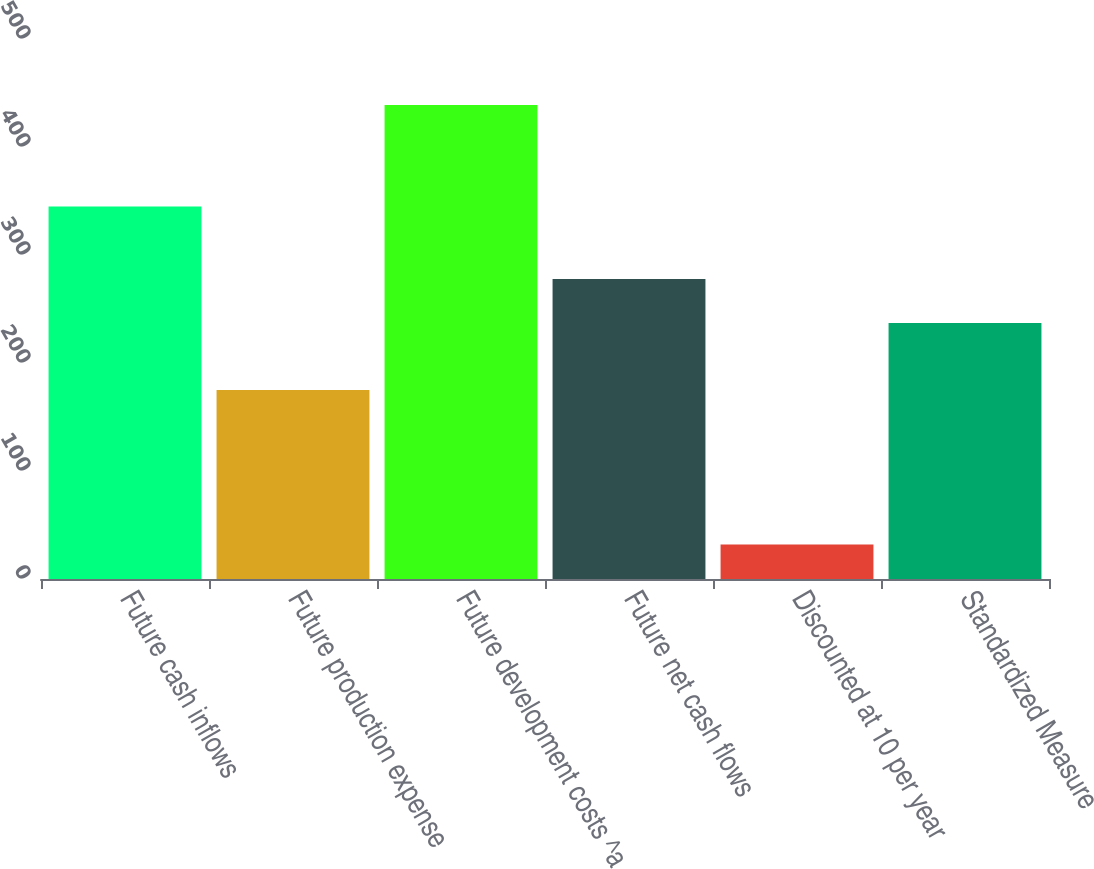Convert chart to OTSL. <chart><loc_0><loc_0><loc_500><loc_500><bar_chart><fcel>Future cash inflows<fcel>Future production expense<fcel>Future development costs ^a<fcel>Future net cash flows<fcel>Discounted at 10 per year<fcel>Standardized Measure<nl><fcel>345<fcel>175<fcel>439<fcel>277.7<fcel>32<fcel>237<nl></chart> 